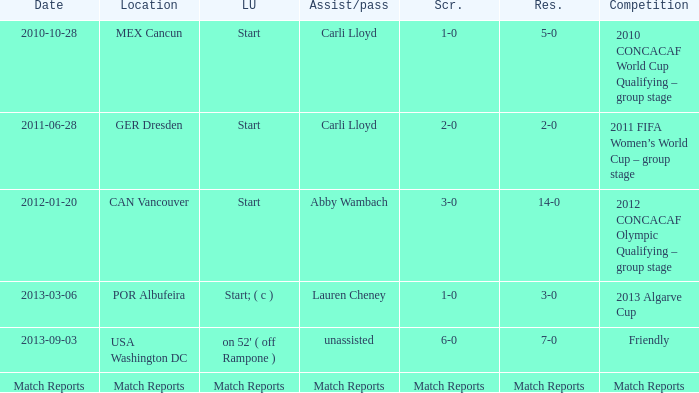Name the Lineup that has an Assist/pass of carli lloyd,a Competition of 2010 concacaf world cup qualifying – group stage? Start. 